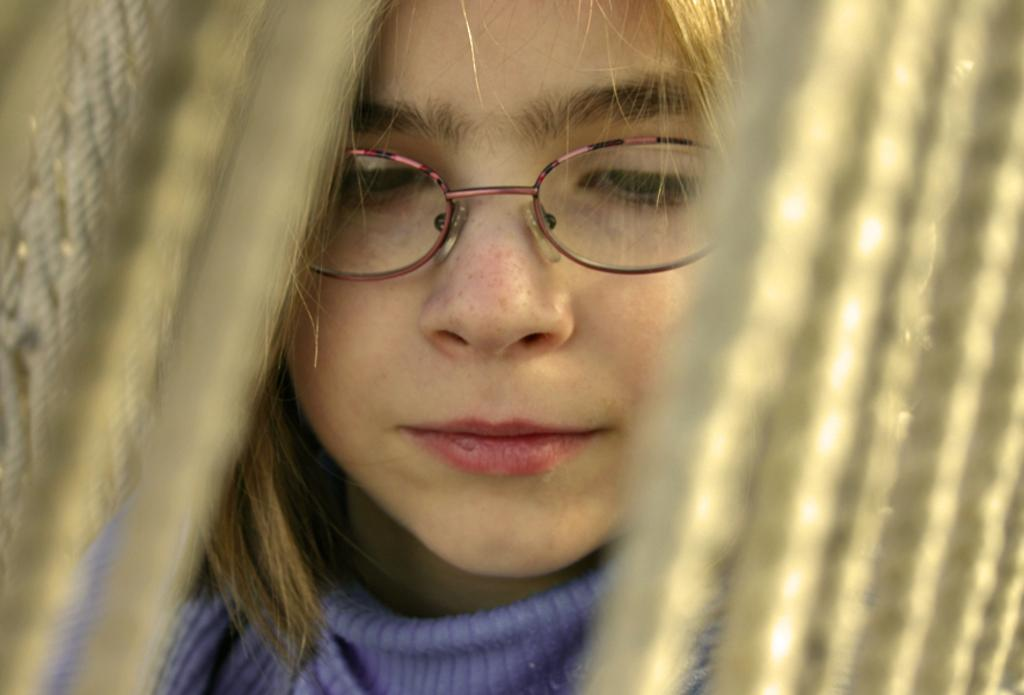Who is the main subject in the image? There is a girl in the image. What is the girl wearing? The girl is wearing spectacles. What else can be seen in the image besides the girl? There are ropes visible in the image. How many eyes can be seen on the girl's disgust in the image? There is no indication of disgust in the image, and the girl's eyes are not visible. 